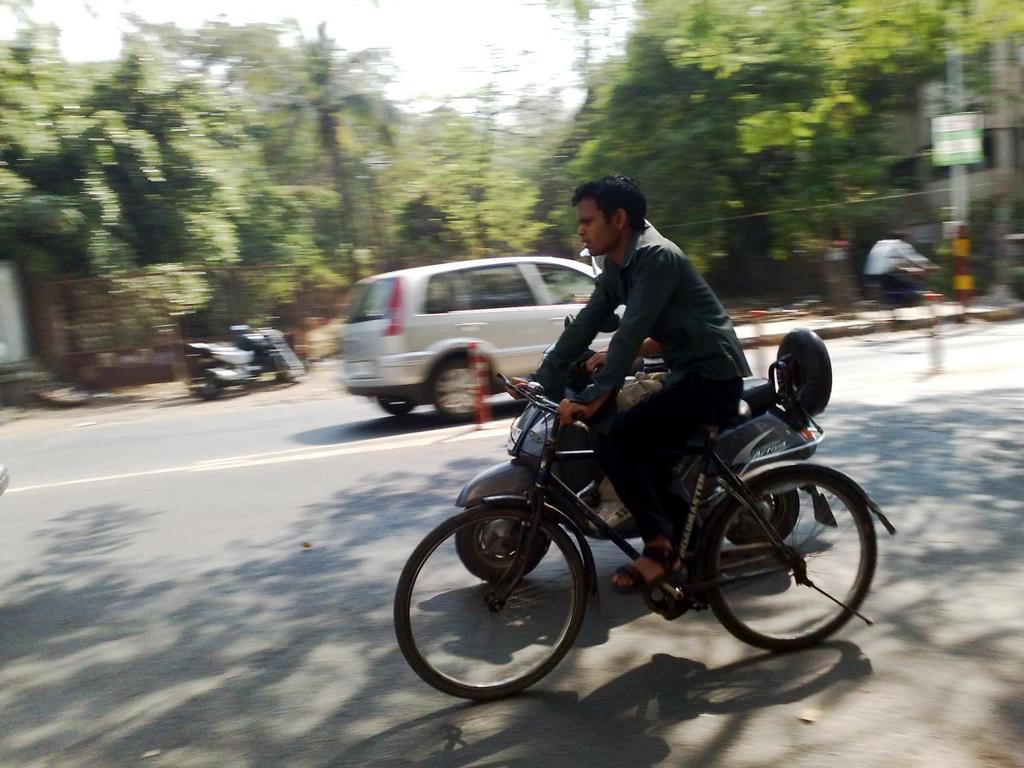Describe this image in one or two sentences. This man is riding a bicycle. Beside this man there is a motorbike. A vehicles on road. Far there are number of trees. 